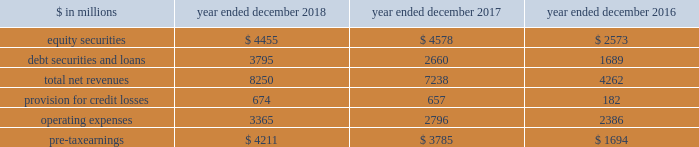The goldman sachs group , inc .
And subsidiaries management 2019s discussion and analysis net revenues in equities were $ 6.60 billion , 4% ( 4 % ) lower than 2016 , primarily due to lower commissions and fees , reflecting a decline in our listed cash equity volumes in the u.s .
Market volumes in the u.s .
Also declined .
In addition , net revenues in equities client execution were lower , reflecting lower net revenues in derivatives , partially offset by higher net revenues in cash products .
Net revenues in securities services were essentially unchanged .
Operating expenses were $ 9.69 billion for 2017 , essentially unchanged compared with 2016 , due to decreased compensation and benefits expenses , reflecting lower net revenues , largely offset by increased technology expenses , reflecting higher expenses related to cloud-based services and software depreciation , and increased consulting costs .
Pre-tax earnings were $ 2.21 billion in 2017 , 54% ( 54 % ) lower than 2016 .
Investing & lending investing & lending includes our investing activities and the origination of loans , including our relationship lending activities , to provide financing to clients .
These investments and loans are typically longer-term in nature .
We make investments , some of which are consolidated , including through our merchant banking business and our special situations group , in debt securities and loans , public and private equity securities , infrastructure and real estate entities .
Some of these investments are made indirectly through funds that we manage .
We also make unsecured loans through our digital platform , marcus : by goldman sachs and secured loans through our digital platform , goldman sachs private bank select .
The table below presents the operating results of our investing & lending segment. .
Operating environment .
During 2018 , our investments in private equities benefited from company-specific events , including sales , and strong corporate performance , while investments in public equities reflected losses , as global equity prices generally decreased .
Results for our investments in debt securities and loans reflected continued growth in loans receivables , resulting in higher net interest income .
If macroeconomic concerns negatively affect corporate performance or the origination of loans , or if global equity prices continue to decline , net revenues in investing & lending would likely be negatively impacted .
During 2017 , generally higher global equity prices and tighter credit spreads contributed to a favorable environment for our equity and debt investments .
Results also reflected net gains from company-specific events , including sales , and corporate performance .
2018 versus 2017 .
Net revenues in investing & lending were $ 8.25 billion for 2018 , 14% ( 14 % ) higher than 2017 .
Net revenues in equity securities were $ 4.46 billion , 3% ( 3 % ) lower than 2017 , reflecting net losses from investments in public equities ( 2018 included $ 183 million of net losses ) compared with net gains in the prior year , partially offset by significantly higher net gains from investments in private equities ( 2018 included $ 4.64 billion of net gains ) , driven by company-specific events , including sales , and corporate performance .
For 2018 , 60% ( 60 % ) of the net revenues in equity securities were generated from corporate investments and 40% ( 40 % ) were generated from real estate .
Net revenues in debt securities and loans were $ 3.80 billion , 43% ( 43 % ) higher than 2017 , primarily driven by significantly higher net interest income .
2018 included net interest income of approximately $ 2.70 billion compared with approximately $ 1.80 billion in 2017 .
Provision for credit losses was $ 674 million for 2018 , compared with $ 657 million for 2017 , as the higher provision for credit losses primarily related to consumer loan growth in 2018 was partially offset by an impairment of approximately $ 130 million on a secured loan in 2017 .
Operating expenses were $ 3.37 billion for 2018 , 20% ( 20 % ) higher than 2017 , primarily due to increased expenses related to consolidated investments and our digital lending and deposit platform , and increased compensation and benefits expenses , reflecting higher net revenues .
Pre-tax earnings were $ 4.21 billion in 2018 , 11% ( 11 % ) higher than 2017 versus 2016 .
Net revenues in investing & lending were $ 7.24 billion for 2017 , 70% ( 70 % ) higher than 2016 .
Net revenues in equity securities were $ 4.58 billion , 78% ( 78 % ) higher than 2016 , primarily reflecting a significant increase in net gains from private equities ( 2017 included $ 3.82 billion of net gains ) , which were positively impacted by company-specific events and corporate performance .
In addition , net gains from public equities ( 2017 included $ 762 million of net gains ) were significantly higher , as global equity prices increased during the year .
For 2017 , 64% ( 64 % ) of the net revenues in equity securities were generated from corporate investments and 36% ( 36 % ) were generated from real estate .
Net revenues in debt securities and loans were $ 2.66 billion , 57% ( 57 % ) higher than 2016 , reflecting significantly higher net interest income ( 2017 included approximately $ 1.80 billion of net interest income ) .
60 goldman sachs 2018 form 10-k .
What were net revenues in investing & lending in billions for 2017? 
Computations: (((100 - 14) / 100) * 8.25)
Answer: 7.095. 